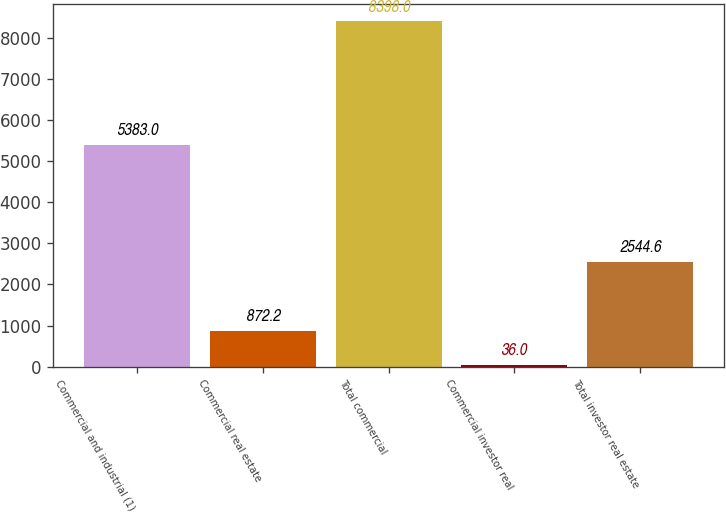Convert chart to OTSL. <chart><loc_0><loc_0><loc_500><loc_500><bar_chart><fcel>Commercial and industrial (1)<fcel>Commercial real estate<fcel>Total commercial<fcel>Commercial investor real<fcel>Total investor real estate<nl><fcel>5383<fcel>872.2<fcel>8398<fcel>36<fcel>2544.6<nl></chart> 